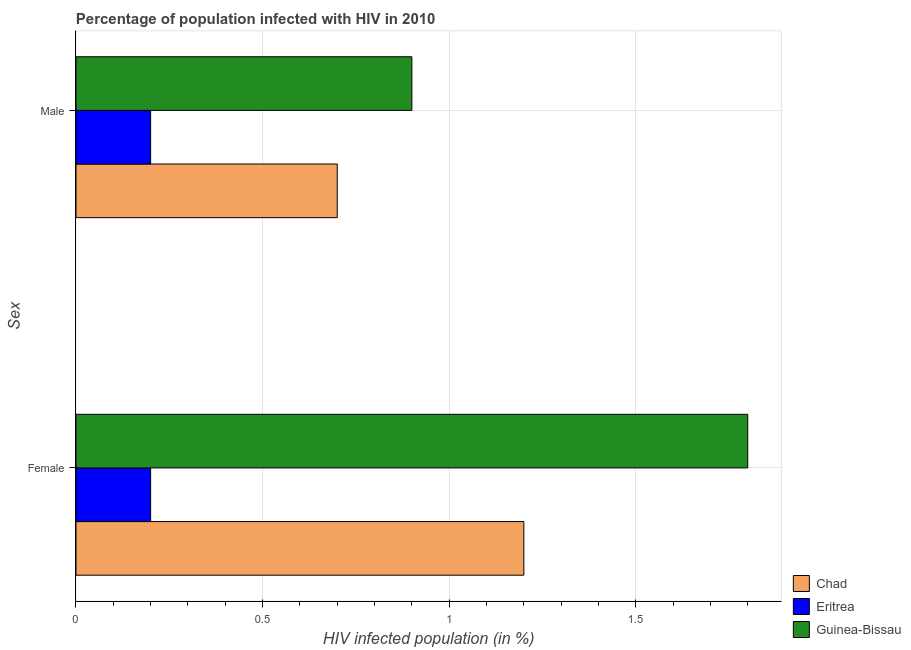How many different coloured bars are there?
Your response must be concise. 3. How many groups of bars are there?
Provide a succinct answer. 2. Are the number of bars per tick equal to the number of legend labels?
Keep it short and to the point. Yes. How many bars are there on the 1st tick from the top?
Give a very brief answer. 3. How many bars are there on the 1st tick from the bottom?
Make the answer very short. 3. Across all countries, what is the minimum percentage of females who are infected with hiv?
Offer a terse response. 0.2. In which country was the percentage of females who are infected with hiv maximum?
Make the answer very short. Guinea-Bissau. In which country was the percentage of females who are infected with hiv minimum?
Your answer should be very brief. Eritrea. What is the difference between the percentage of males who are infected with hiv in Chad and the percentage of females who are infected with hiv in Eritrea?
Keep it short and to the point. 0.5. What is the average percentage of males who are infected with hiv per country?
Your response must be concise. 0.6. In how many countries, is the percentage of females who are infected with hiv greater than 1.6 %?
Provide a succinct answer. 1. What is the ratio of the percentage of males who are infected with hiv in Eritrea to that in Chad?
Offer a very short reply. 0.29. Is the percentage of females who are infected with hiv in Eritrea less than that in Chad?
Make the answer very short. Yes. In how many countries, is the percentage of males who are infected with hiv greater than the average percentage of males who are infected with hiv taken over all countries?
Provide a succinct answer. 2. What does the 1st bar from the top in Male represents?
Ensure brevity in your answer.  Guinea-Bissau. What does the 2nd bar from the bottom in Male represents?
Ensure brevity in your answer.  Eritrea. How many bars are there?
Offer a very short reply. 6. How many countries are there in the graph?
Offer a terse response. 3. What is the difference between two consecutive major ticks on the X-axis?
Offer a terse response. 0.5. Are the values on the major ticks of X-axis written in scientific E-notation?
Your answer should be compact. No. Does the graph contain any zero values?
Your answer should be compact. No. How are the legend labels stacked?
Your answer should be compact. Vertical. What is the title of the graph?
Your response must be concise. Percentage of population infected with HIV in 2010. What is the label or title of the X-axis?
Make the answer very short. HIV infected population (in %). What is the label or title of the Y-axis?
Offer a very short reply. Sex. What is the HIV infected population (in %) in Chad in Female?
Provide a succinct answer. 1.2. What is the HIV infected population (in %) of Guinea-Bissau in Female?
Provide a succinct answer. 1.8. What is the HIV infected population (in %) in Chad in Male?
Your answer should be very brief. 0.7. What is the HIV infected population (in %) in Guinea-Bissau in Male?
Provide a succinct answer. 0.9. Across all Sex, what is the maximum HIV infected population (in %) of Guinea-Bissau?
Offer a very short reply. 1.8. Across all Sex, what is the minimum HIV infected population (in %) of Chad?
Your response must be concise. 0.7. Across all Sex, what is the minimum HIV infected population (in %) in Guinea-Bissau?
Make the answer very short. 0.9. What is the total HIV infected population (in %) in Chad in the graph?
Your response must be concise. 1.9. What is the difference between the HIV infected population (in %) of Chad in Female and that in Male?
Your answer should be compact. 0.5. What is the difference between the HIV infected population (in %) in Eritrea in Female and that in Male?
Provide a short and direct response. 0. What is the difference between the HIV infected population (in %) of Guinea-Bissau in Female and that in Male?
Your answer should be compact. 0.9. What is the difference between the HIV infected population (in %) in Chad in Female and the HIV infected population (in %) in Eritrea in Male?
Offer a terse response. 1. What is the difference between the HIV infected population (in %) in Chad in Female and the HIV infected population (in %) in Guinea-Bissau in Male?
Provide a short and direct response. 0.3. What is the difference between the HIV infected population (in %) of Eritrea in Female and the HIV infected population (in %) of Guinea-Bissau in Male?
Offer a terse response. -0.7. What is the average HIV infected population (in %) in Eritrea per Sex?
Make the answer very short. 0.2. What is the average HIV infected population (in %) of Guinea-Bissau per Sex?
Offer a very short reply. 1.35. What is the difference between the HIV infected population (in %) in Chad and HIV infected population (in %) in Guinea-Bissau in Female?
Your answer should be compact. -0.6. What is the difference between the HIV infected population (in %) of Chad and HIV infected population (in %) of Eritrea in Male?
Offer a very short reply. 0.5. What is the difference between the HIV infected population (in %) in Chad and HIV infected population (in %) in Guinea-Bissau in Male?
Provide a short and direct response. -0.2. What is the ratio of the HIV infected population (in %) in Chad in Female to that in Male?
Offer a terse response. 1.71. What is the ratio of the HIV infected population (in %) in Guinea-Bissau in Female to that in Male?
Your response must be concise. 2. What is the difference between the highest and the second highest HIV infected population (in %) of Chad?
Make the answer very short. 0.5. What is the difference between the highest and the second highest HIV infected population (in %) of Guinea-Bissau?
Provide a short and direct response. 0.9. What is the difference between the highest and the lowest HIV infected population (in %) in Chad?
Make the answer very short. 0.5. 